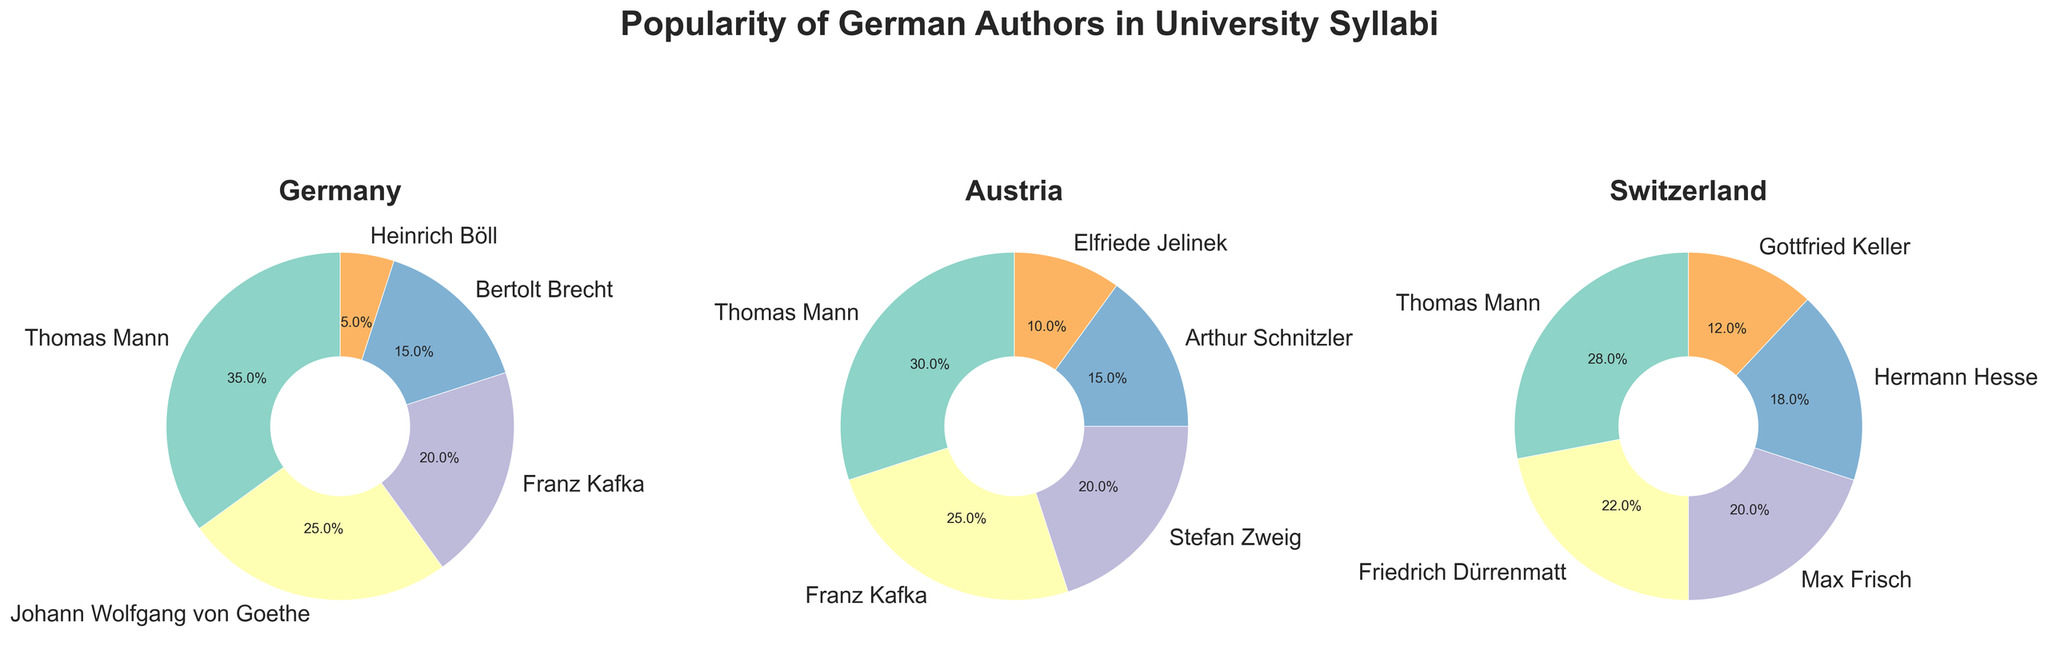What is the percentage of Thomas Mann's popularity in Germany's university syllabi? Look at the pie chart for Germany and find the segment labeled 'Thomas Mann'. The percentage indicated is 35%.
Answer: 35% Which author is most popular in Swiss university syllabi? Look at the pie chart for Switzerland and identify the largest segment. The label 'Thomas Mann' shows he is the most popular.
Answer: Thomas Mann What is the combined percentage of Franz Kafka's popularity in Germany and Austria? Find Franz Kafka's percentage in Germany (20%) and Austria (25%). Sum these percentages: 20% + 25% = 45%.
Answer: 45% Is Thomas Mann more popular in Austria or Switzerland? Look at the pie charts for Austria and Switzerland and compare the segments for Thomas Mann. Austria shows 30%, while Switzerland shows 28%, making him more popular in Austria.
Answer: Austria What is the least represented author in the German university syllabi? Look at the pie chart for Germany and find the smallest segment. 'Heinrich Böll' is labeled with 5%, the smallest percentage.
Answer: Heinrich Böll Which three authors appear in all three countries' syllabi? Look at each pie chart and identify the authors listed. Thomas Mann and Franz Kafka are present in all three countries, but no third author is.
Answer: Thomas Mann, None What is the difference in popularity percentage between Thomas Mann and Johann Wolfgang von Goethe in Germany? Find the percentages for Thomas Mann (35%) and Johann Wolfgang von Goethe (25%) in the German pie chart. Subtract the smaller from the larger: 35% - 25% = 10%.
Answer: 10% Which author has the second highest popularity in Switzerland? Look at the pie chart for Switzerland and find the second largest segment. Friedrich Dürrenmatt has 22%, which is the second largest.
Answer: Friedrich Dürrenmatt How does the popularity of Hermann Hesse in Switzerland compare to Stefan Zweig in Austria? Hermann Hesse in Switzerland has 18%, while Stefan Zweig in Austria has 20%. Compare the two: 18% < 20%, so Hesse is less popular.
Answer: Less popular What is the average popularity percentage of Thomas Mann across the three countries? Find Thomas Mann's percentages in Germany (35%), Austria (30%), and Switzerland (28%). Average these: (35% + 30% + 28%)/3 = 31%.
Answer: 31% 